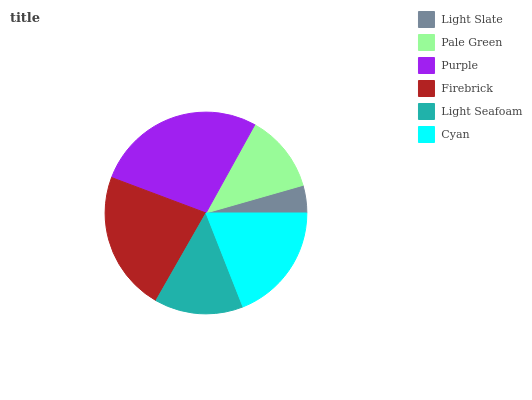Is Light Slate the minimum?
Answer yes or no. Yes. Is Purple the maximum?
Answer yes or no. Yes. Is Pale Green the minimum?
Answer yes or no. No. Is Pale Green the maximum?
Answer yes or no. No. Is Pale Green greater than Light Slate?
Answer yes or no. Yes. Is Light Slate less than Pale Green?
Answer yes or no. Yes. Is Light Slate greater than Pale Green?
Answer yes or no. No. Is Pale Green less than Light Slate?
Answer yes or no. No. Is Cyan the high median?
Answer yes or no. Yes. Is Light Seafoam the low median?
Answer yes or no. Yes. Is Purple the high median?
Answer yes or no. No. Is Light Slate the low median?
Answer yes or no. No. 